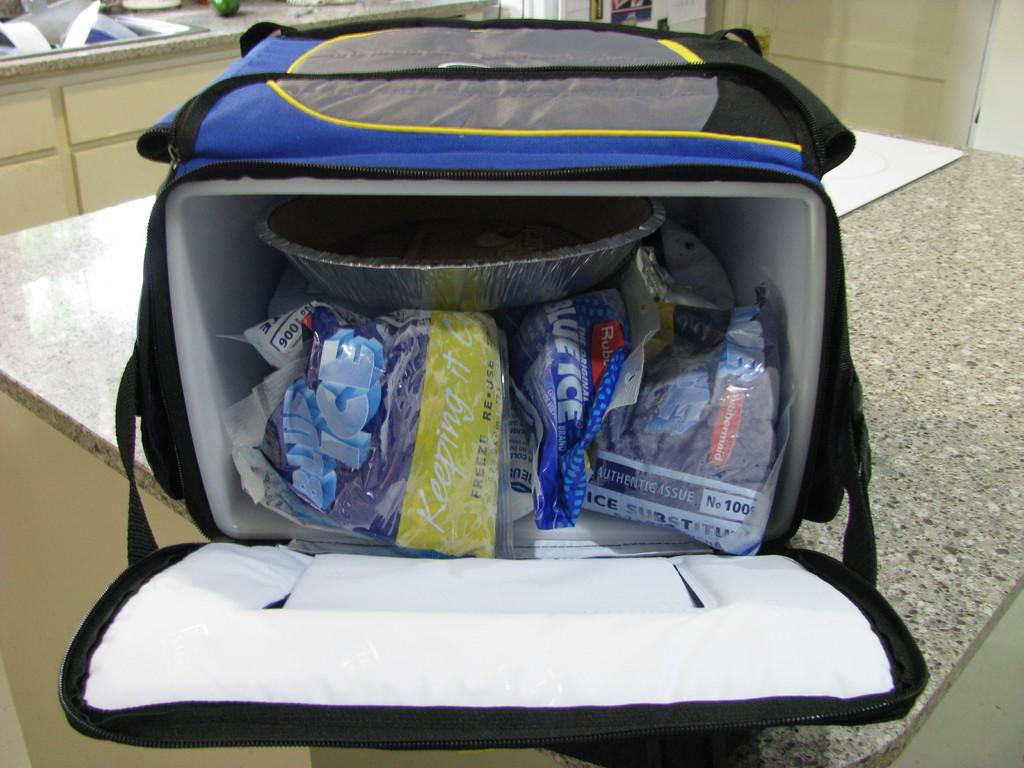What is the main piece of furniture in the image? There is a table in the image. What is on top of the table? There is a covered bowl, papers, and a bag on the table. What can be seen in the background of the image? There is a wall and a door in the background of the image. How many harbors can be seen in the image? There are no harbors present in the image. What is the fifth item on the table in the image? There is no fifth item on the table in the image, as only four items are mentioned in the facts (covered bowl, papers, and bag). 